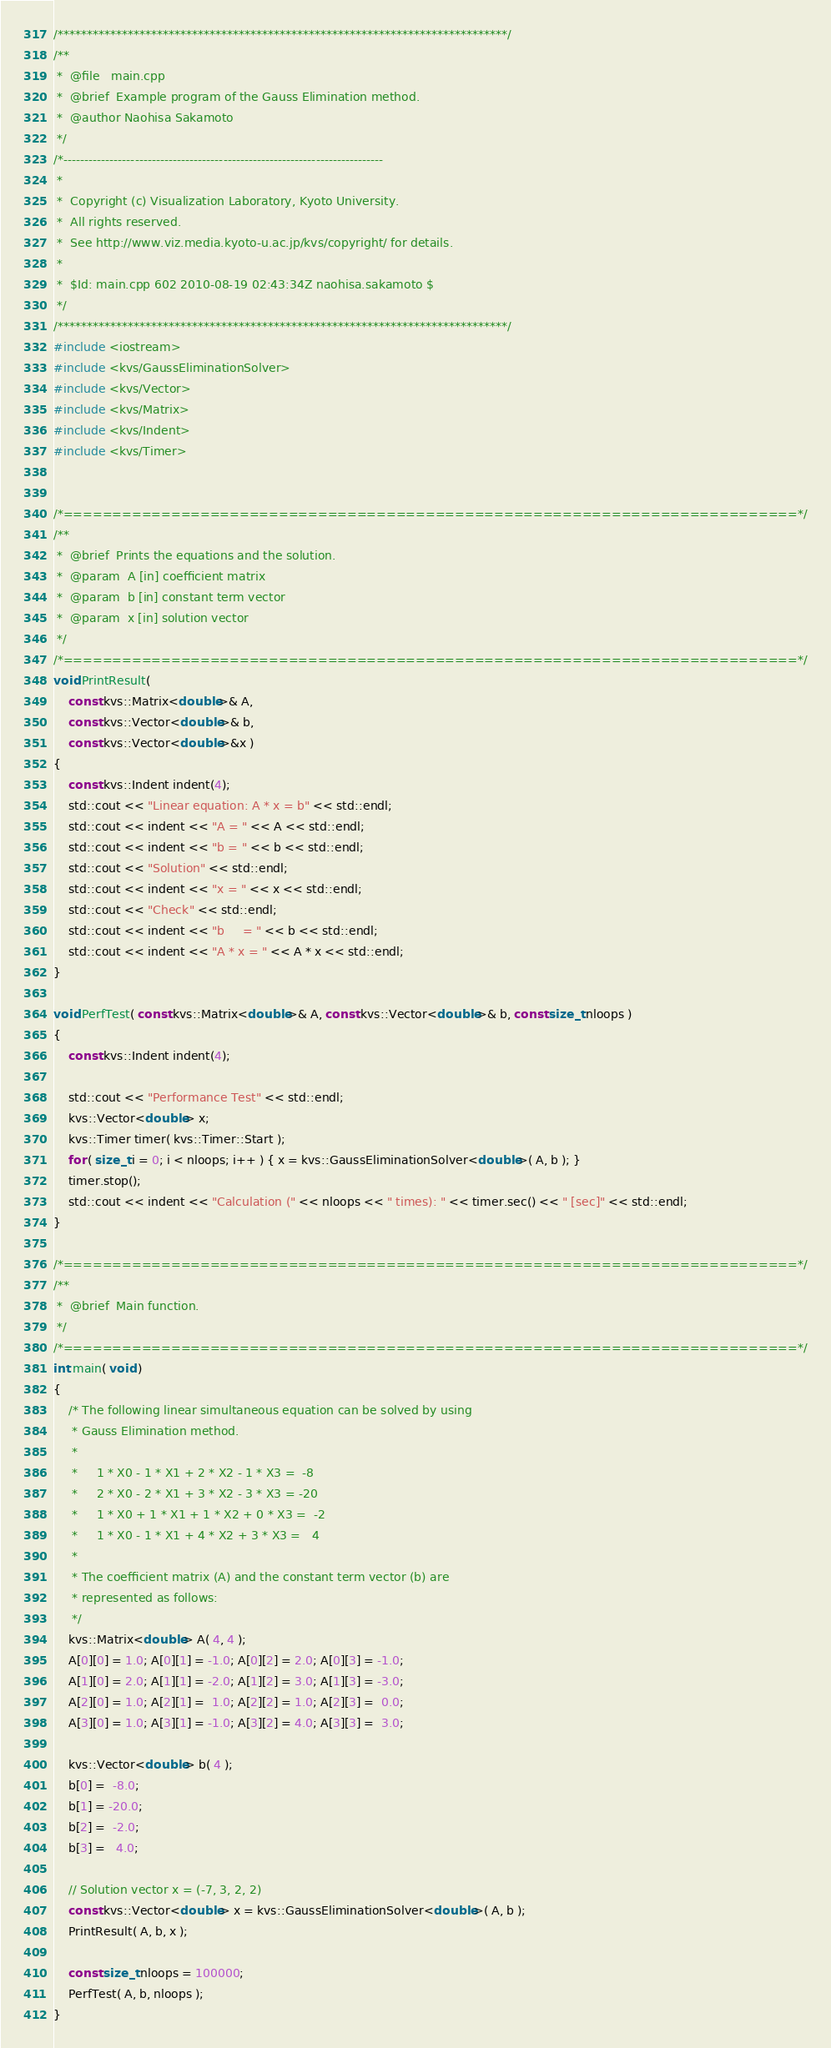Convert code to text. <code><loc_0><loc_0><loc_500><loc_500><_C++_>/*****************************************************************************/
/**
 *  @file   main.cpp
 *  @brief  Example program of the Gauss Elimination method.
 *  @author Naohisa Sakamoto
 */
/*----------------------------------------------------------------------------
 *
 *  Copyright (c) Visualization Laboratory, Kyoto University.
 *  All rights reserved.
 *  See http://www.viz.media.kyoto-u.ac.jp/kvs/copyright/ for details.
 *
 *  $Id: main.cpp 602 2010-08-19 02:43:34Z naohisa.sakamoto $
 */
/*****************************************************************************/
#include <iostream>
#include <kvs/GaussEliminationSolver>
#include <kvs/Vector>
#include <kvs/Matrix>
#include <kvs/Indent>
#include <kvs/Timer>


/*===========================================================================*/
/**
 *  @brief  Prints the equations and the solution.
 *  @param  A [in] coefficient matrix
 *  @param  b [in] constant term vector
 *  @param  x [in] solution vector
 */
/*===========================================================================*/
void PrintResult(
    const kvs::Matrix<double>& A,
    const kvs::Vector<double>& b,
    const kvs::Vector<double>&x )
{
    const kvs::Indent indent(4);
    std::cout << "Linear equation: A * x = b" << std::endl;
    std::cout << indent << "A = " << A << std::endl;
    std::cout << indent << "b = " << b << std::endl;
    std::cout << "Solution" << std::endl;
    std::cout << indent << "x = " << x << std::endl;
    std::cout << "Check" << std::endl;
    std::cout << indent << "b     = " << b << std::endl;
    std::cout << indent << "A * x = " << A * x << std::endl;
}

void PerfTest( const kvs::Matrix<double>& A, const kvs::Vector<double>& b, const size_t nloops )
{
    const kvs::Indent indent(4);

    std::cout << "Performance Test" << std::endl;
    kvs::Vector<double> x;
    kvs::Timer timer( kvs::Timer::Start );
    for ( size_t i = 0; i < nloops; i++ ) { x = kvs::GaussEliminationSolver<double>( A, b ); }
    timer.stop();
    std::cout << indent << "Calculation (" << nloops << " times): " << timer.sec() << " [sec]" << std::endl;
}

/*===========================================================================*/
/**
 *  @brief  Main function.
 */
/*===========================================================================*/
int main( void )
{
    /* The following linear simultaneous equation can be solved by using
     * Gauss Elimination method.
     *
     *     1 * X0 - 1 * X1 + 2 * X2 - 1 * X3 =  -8
     *     2 * X0 - 2 * X1 + 3 * X2 - 3 * X3 = -20
     *     1 * X0 + 1 * X1 + 1 * X2 + 0 * X3 =  -2
     *     1 * X0 - 1 * X1 + 4 * X2 + 3 * X3 =   4
     *
     * The coefficient matrix (A) and the constant term vector (b) are
     * represented as follows:
     */
    kvs::Matrix<double> A( 4, 4 );
    A[0][0] = 1.0; A[0][1] = -1.0; A[0][2] = 2.0; A[0][3] = -1.0;
    A[1][0] = 2.0; A[1][1] = -2.0; A[1][2] = 3.0; A[1][3] = -3.0;
    A[2][0] = 1.0; A[2][1] =  1.0; A[2][2] = 1.0; A[2][3] =  0.0;
    A[3][0] = 1.0; A[3][1] = -1.0; A[3][2] = 4.0; A[3][3] =  3.0;

    kvs::Vector<double> b( 4 );
    b[0] =  -8.0;
    b[1] = -20.0;
    b[2] =  -2.0;
    b[3] =   4.0;

    // Solution vector x = (-7, 3, 2, 2)
    const kvs::Vector<double> x = kvs::GaussEliminationSolver<double>( A, b );
    PrintResult( A, b, x );

    const size_t nloops = 100000;
    PerfTest( A, b, nloops );
}
</code> 